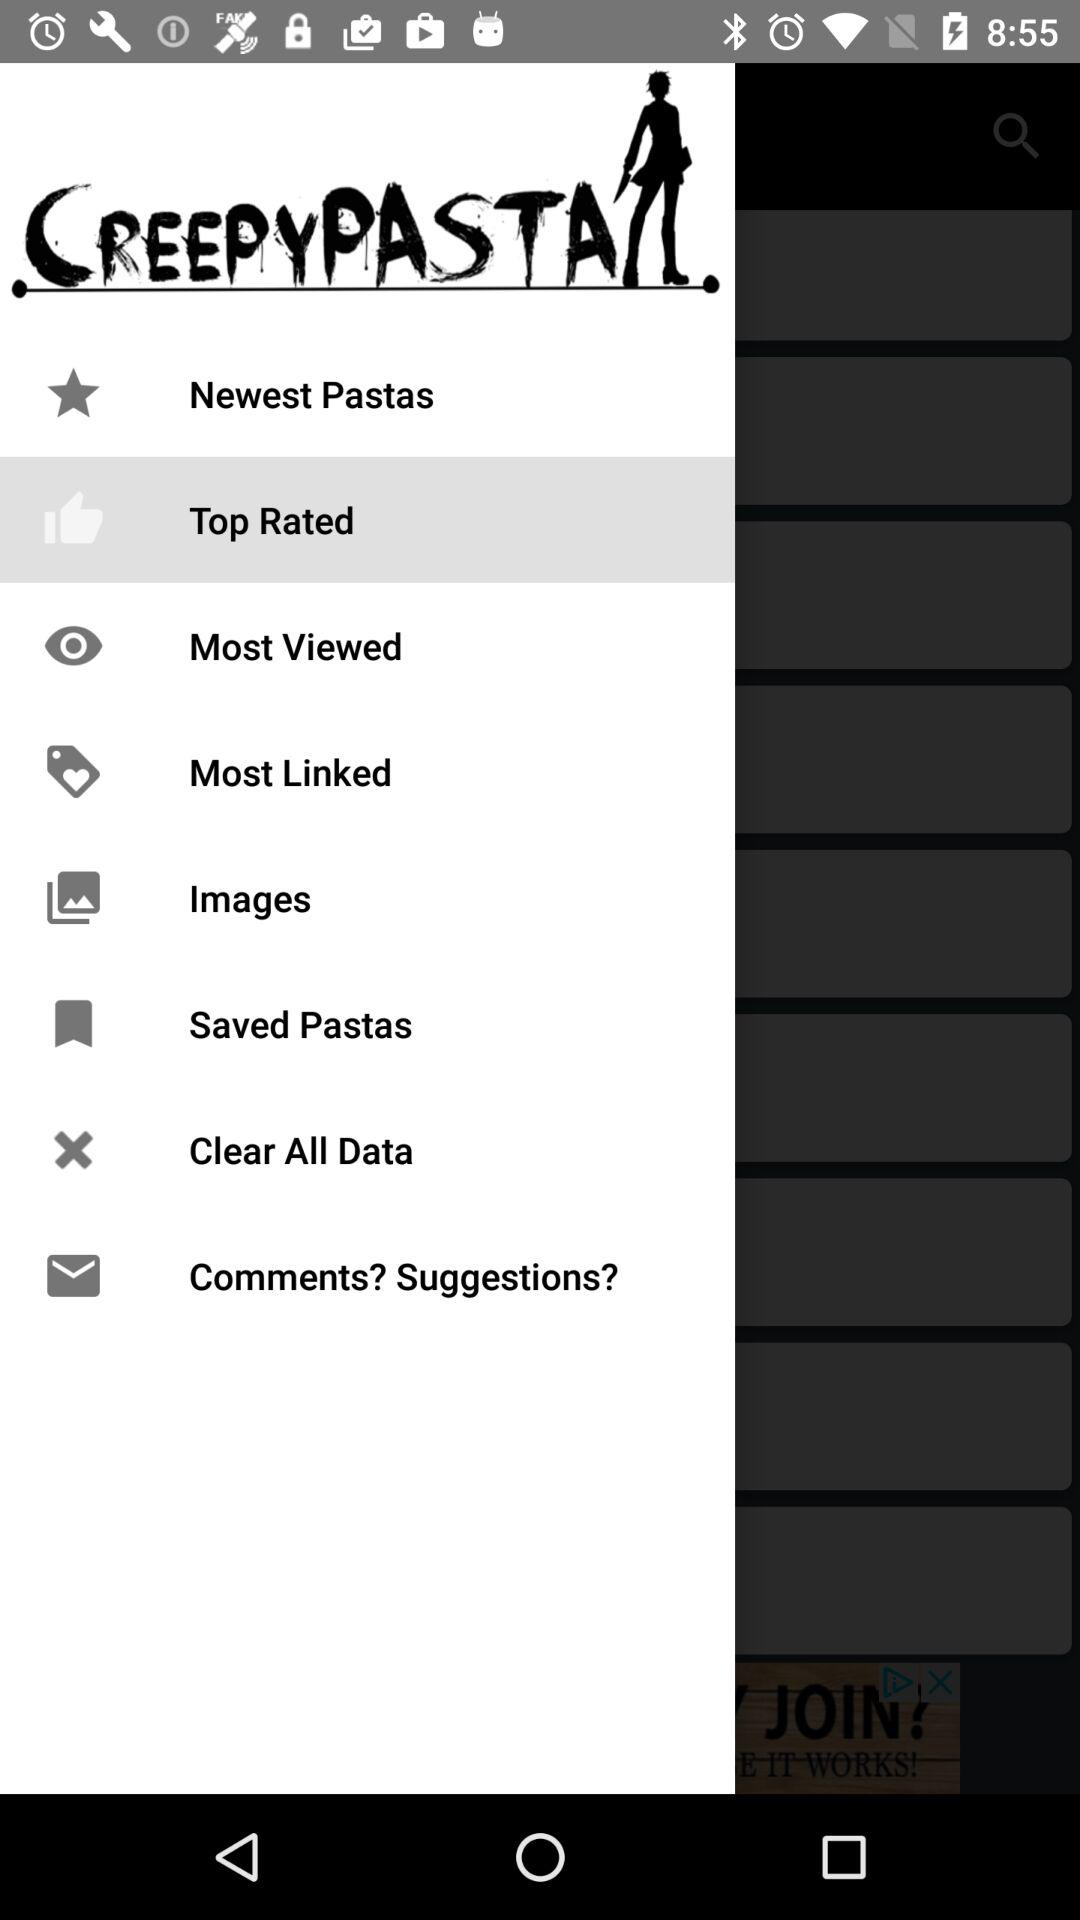What is the application name? The application name is "CREEPYPASTA". 